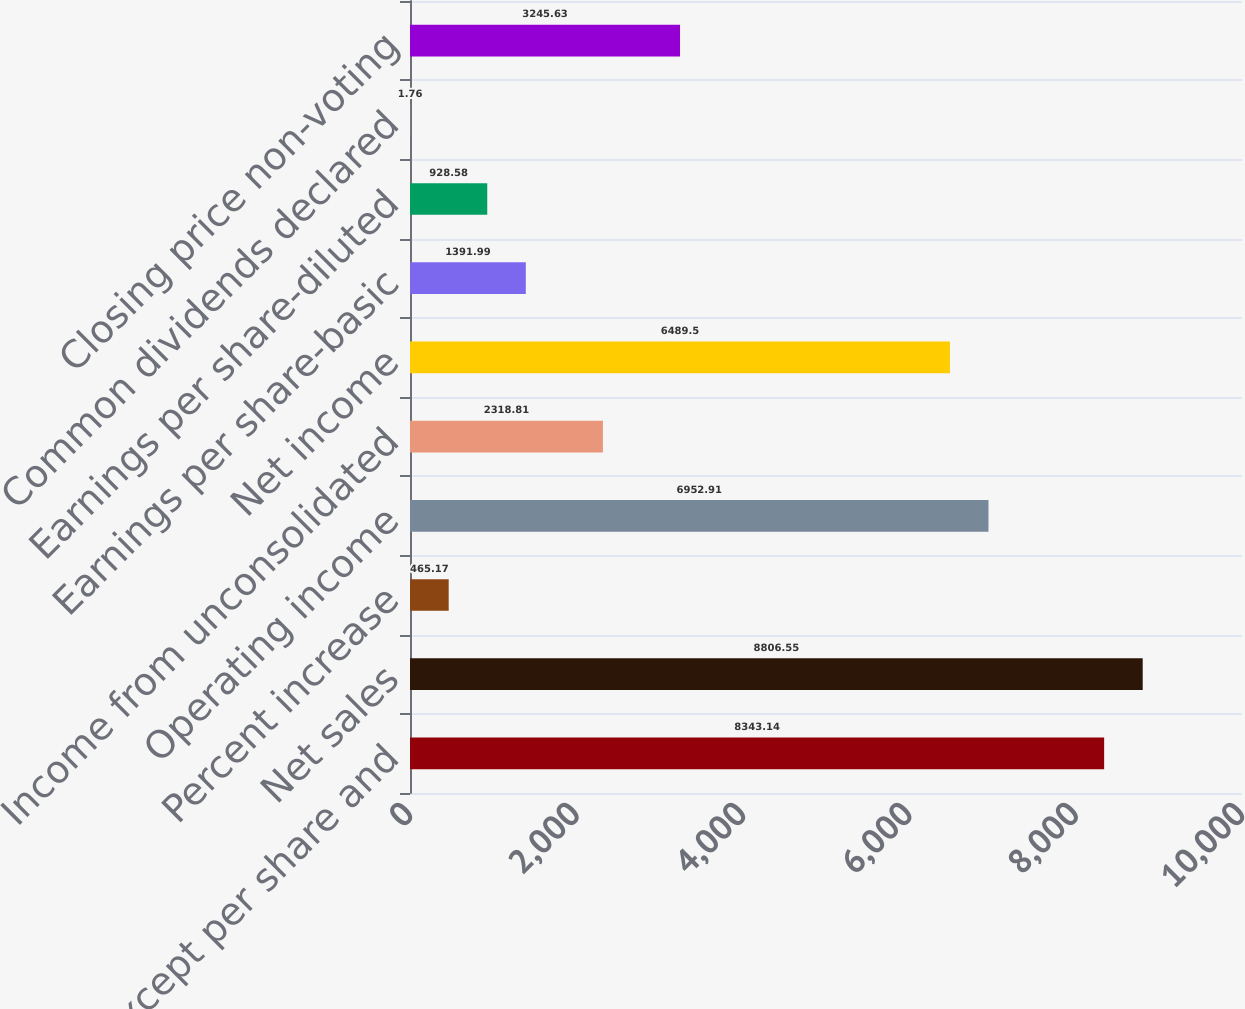<chart> <loc_0><loc_0><loc_500><loc_500><bar_chart><fcel>(millions except per share and<fcel>Net sales<fcel>Percent increase<fcel>Operating income<fcel>Income from unconsolidated<fcel>Net income<fcel>Earnings per share-basic<fcel>Earnings per share-diluted<fcel>Common dividends declared<fcel>Closing price non-voting<nl><fcel>8343.14<fcel>8806.55<fcel>465.17<fcel>6952.91<fcel>2318.81<fcel>6489.5<fcel>1391.99<fcel>928.58<fcel>1.76<fcel>3245.63<nl></chart> 